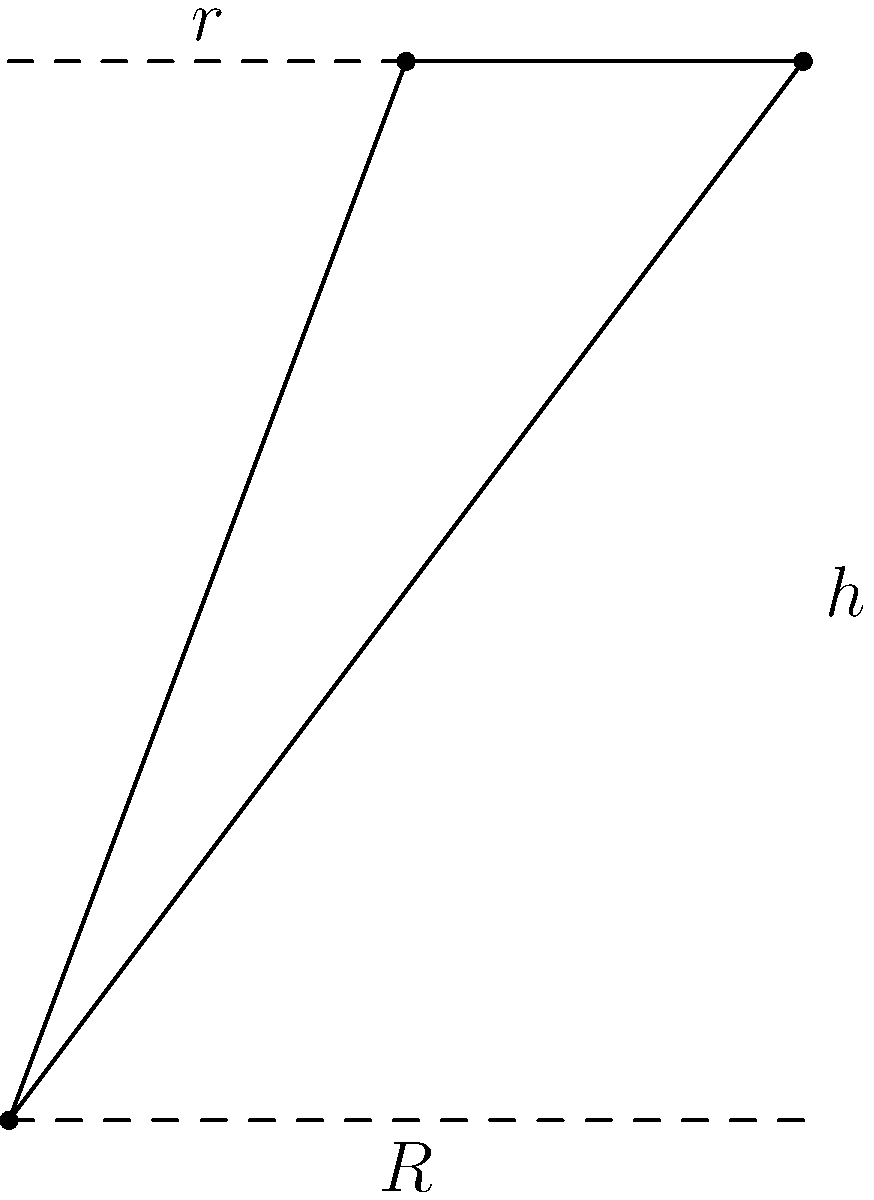As a newly hired employee balancing work and studies, you're tasked with optimizing storage solutions. Calculate the volume of a truncated cone-shaped container with a bottom radius of 3 units, a top radius of 1.5 units, and a height of 4 units. Round your answer to two decimal places. To calculate the volume of a truncated cone, we'll use the formula:

$$V = \frac{1}{3}\pi h(R^2 + r^2 + Rr)$$

Where:
$V$ = volume
$h$ = height
$R$ = radius of the base
$r$ = radius of the top

Given:
$h = 4$ units
$R = 3$ units
$r = 1.5$ units

Let's substitute these values into the formula:

$$V = \frac{1}{3}\pi \cdot 4(3^2 + 1.5^2 + 3 \cdot 1.5)$$

Simplify:
$$V = \frac{4\pi}{3}(9 + 2.25 + 4.5)$$
$$V = \frac{4\pi}{3}(15.75)$$
$$V = 21\pi$$

Calculate and round to two decimal places:
$$V \approx 65.97 \text{ cubic units}$$
Answer: 65.97 cubic units 